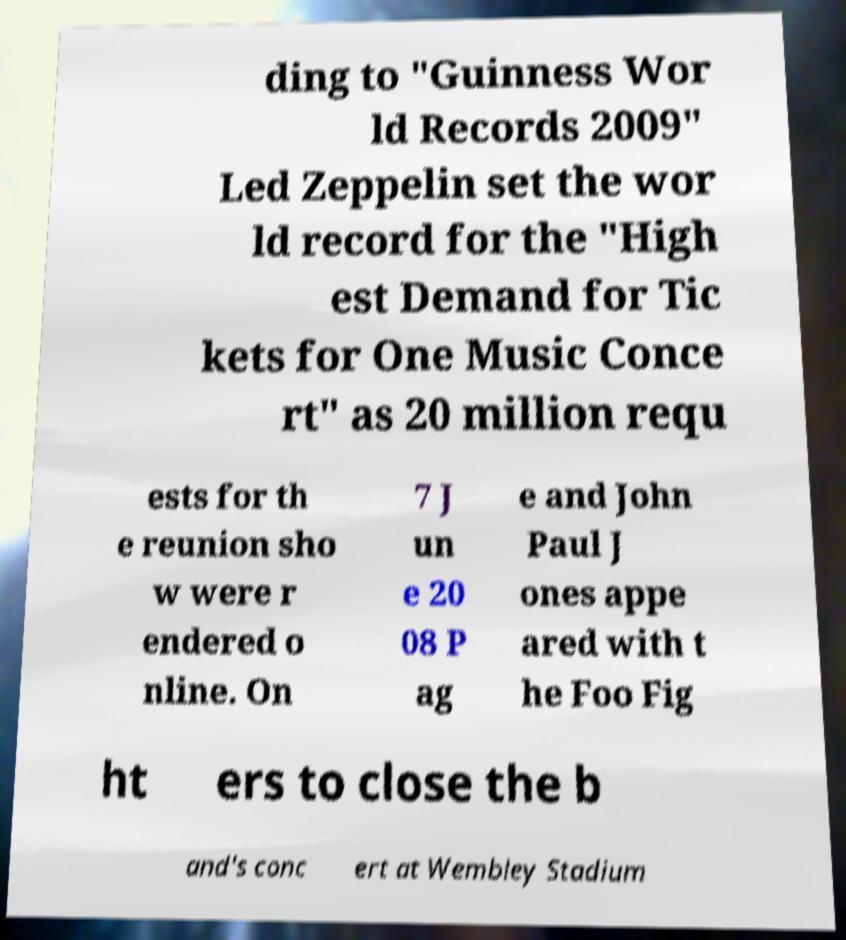Could you assist in decoding the text presented in this image and type it out clearly? ding to "Guinness Wor ld Records 2009" Led Zeppelin set the wor ld record for the "High est Demand for Tic kets for One Music Conce rt" as 20 million requ ests for th e reunion sho w were r endered o nline. On 7 J un e 20 08 P ag e and John Paul J ones appe ared with t he Foo Fig ht ers to close the b and's conc ert at Wembley Stadium 